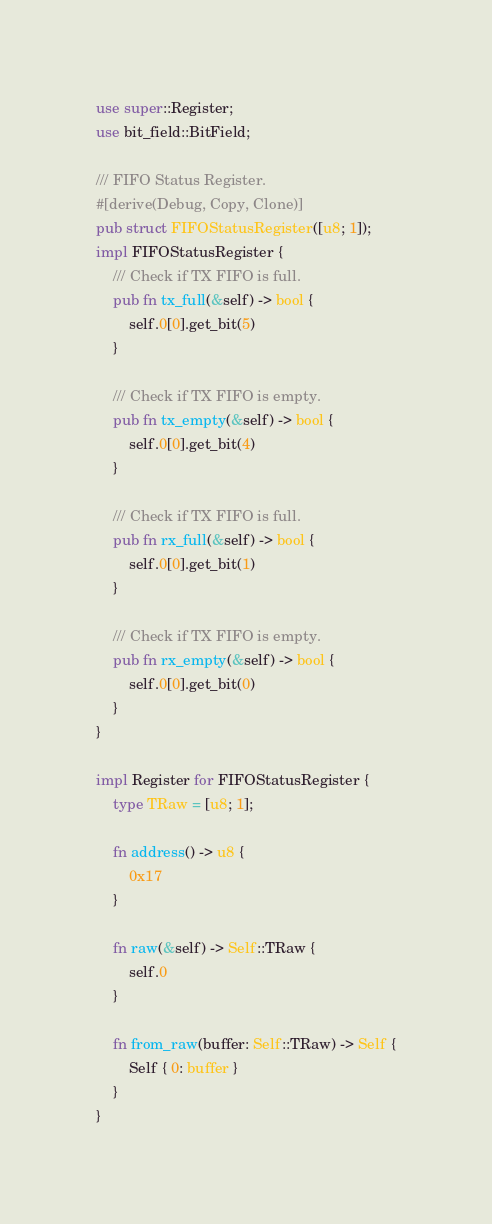Convert code to text. <code><loc_0><loc_0><loc_500><loc_500><_Rust_>use super::Register;
use bit_field::BitField;

/// FIFO Status Register.
#[derive(Debug, Copy, Clone)]
pub struct FIFOStatusRegister([u8; 1]);
impl FIFOStatusRegister {
    /// Check if TX FIFO is full.
    pub fn tx_full(&self) -> bool {
        self.0[0].get_bit(5)
    }

    /// Check if TX FIFO is empty.
    pub fn tx_empty(&self) -> bool {
        self.0[0].get_bit(4)
    }

    /// Check if TX FIFO is full.
    pub fn rx_full(&self) -> bool {
        self.0[0].get_bit(1)
    }

    /// Check if TX FIFO is empty.
    pub fn rx_empty(&self) -> bool {
        self.0[0].get_bit(0)
    }
}

impl Register for FIFOStatusRegister {
    type TRaw = [u8; 1];

    fn address() -> u8 {
        0x17
    }

    fn raw(&self) -> Self::TRaw {
        self.0
    }

    fn from_raw(buffer: Self::TRaw) -> Self {
        Self { 0: buffer }
    }
}
</code> 